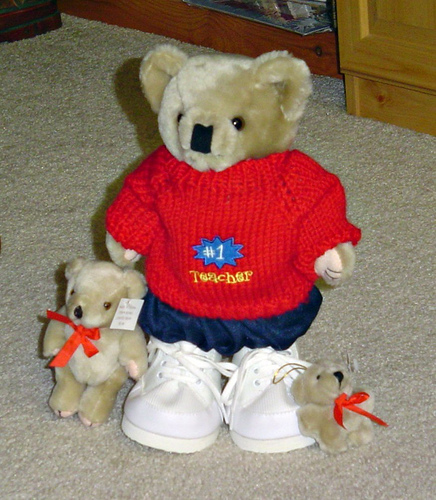<image>
Is there a baby shoes under the teddy bear? Yes. The baby shoes is positioned underneath the teddy bear, with the teddy bear above it in the vertical space. 